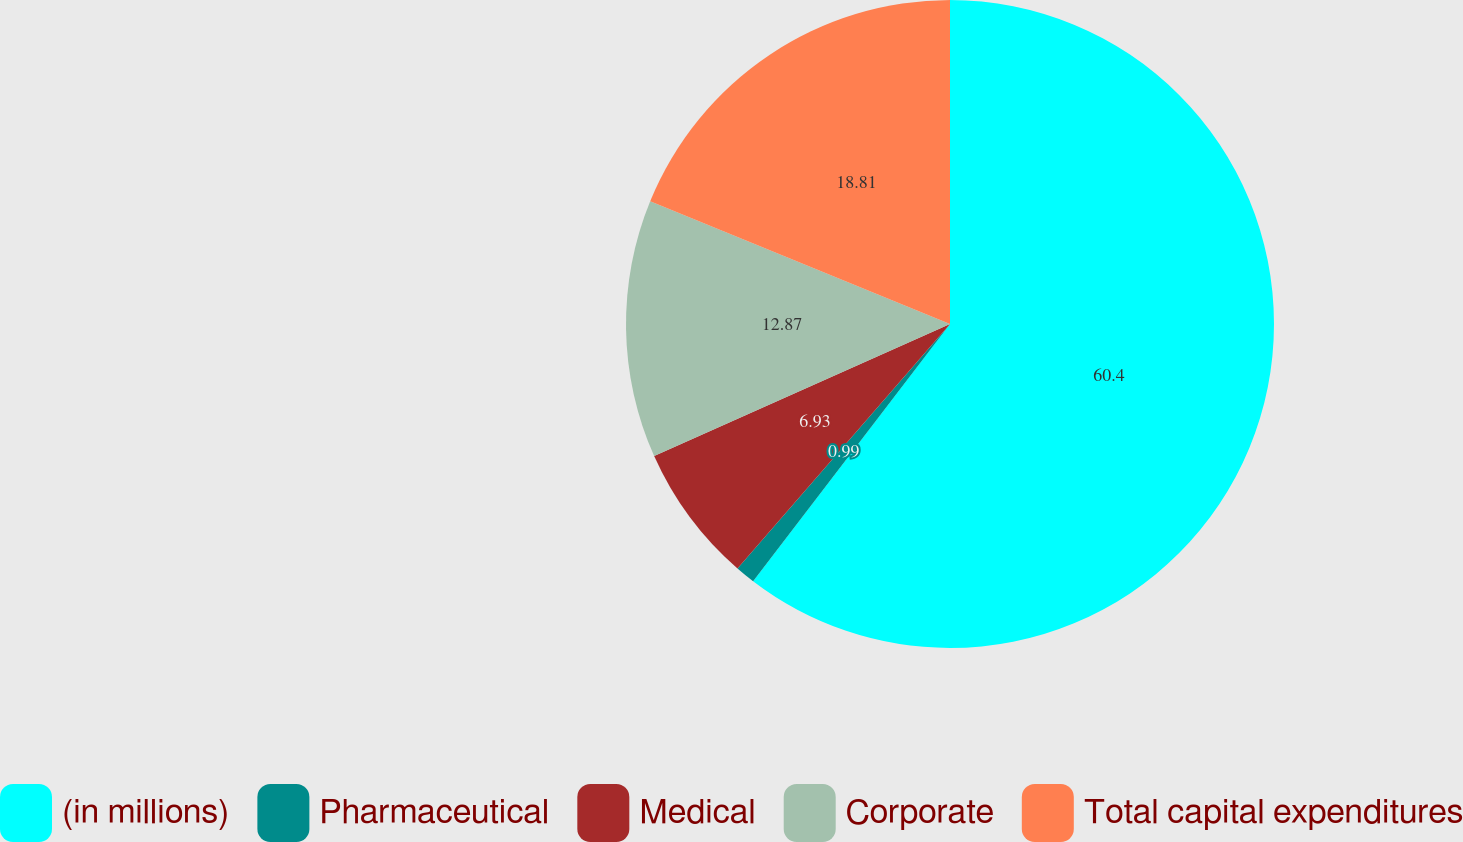Convert chart. <chart><loc_0><loc_0><loc_500><loc_500><pie_chart><fcel>(in millions)<fcel>Pharmaceutical<fcel>Medical<fcel>Corporate<fcel>Total capital expenditures<nl><fcel>60.39%<fcel>0.99%<fcel>6.93%<fcel>12.87%<fcel>18.81%<nl></chart> 